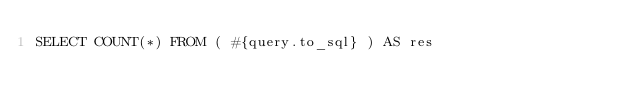Convert code to text. <code><loc_0><loc_0><loc_500><loc_500><_SQL_>SELECT COUNT(*) FROM ( #{query.to_sql} ) AS res
</code> 